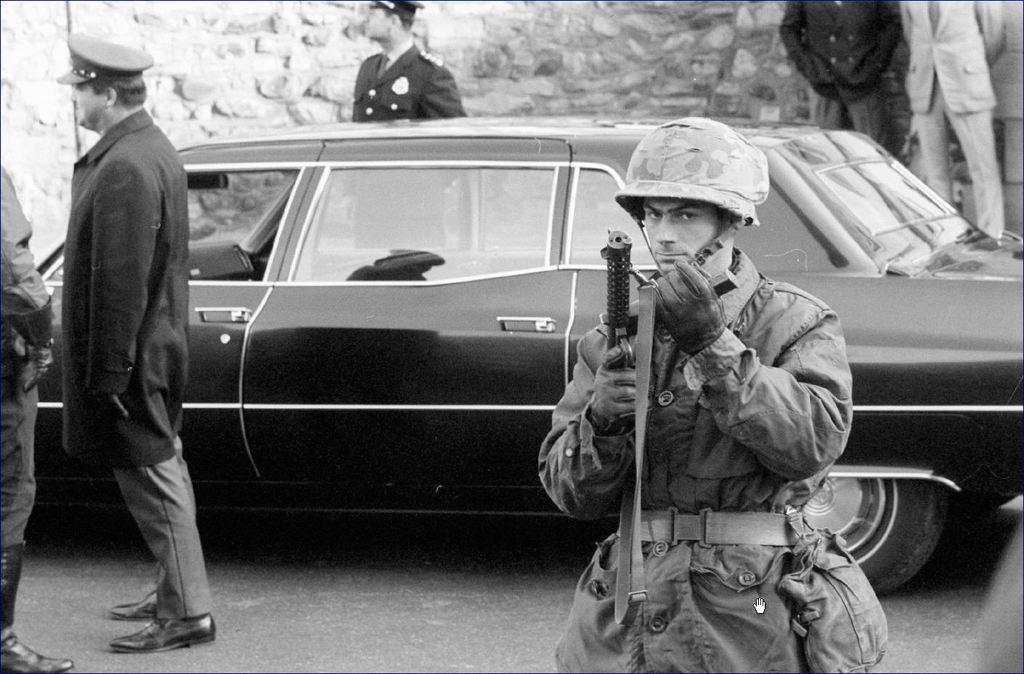Please provide a concise description of this image. This is a black and white image. On the left side, there is a person in a suit, standing. Beside him, there is another person standing. On the right side, there is a person in a uniform, holding a gun. In the background, there are persons and there is a wall. 